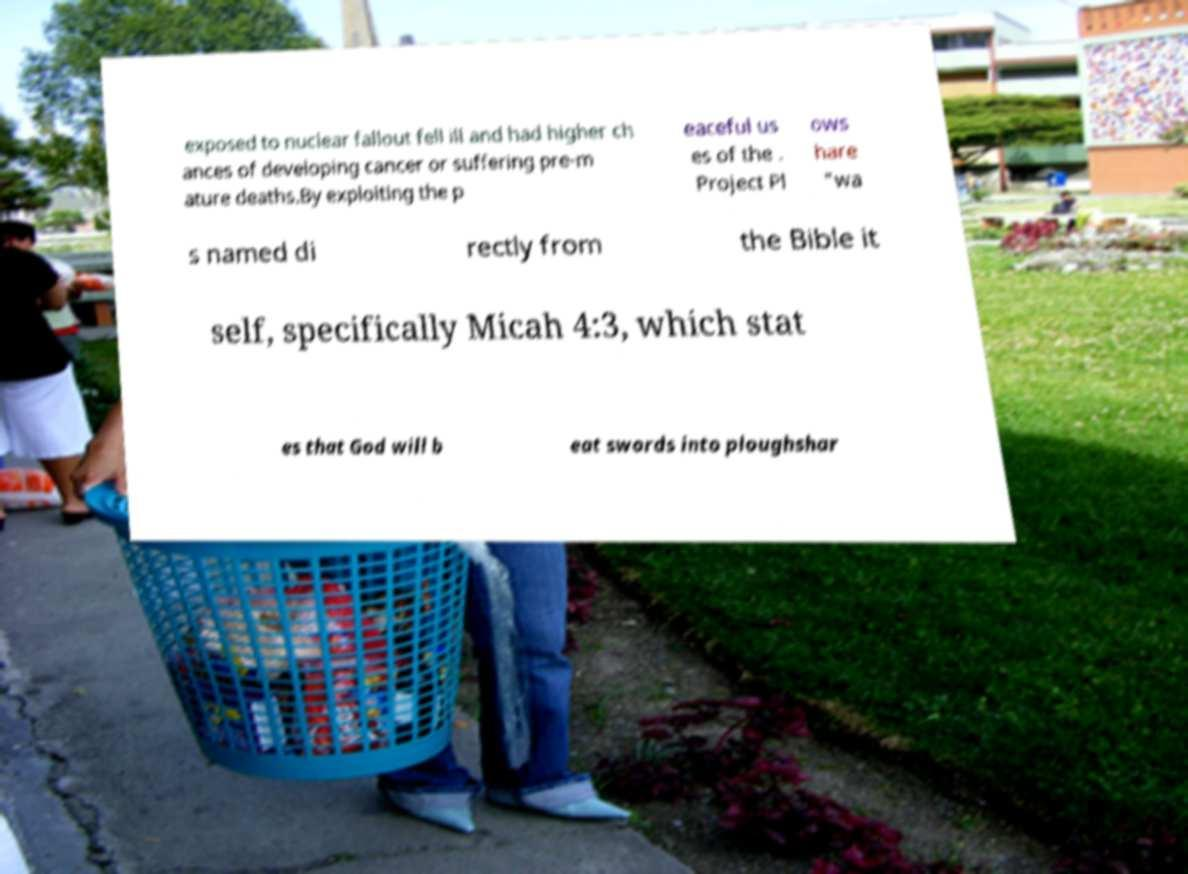Could you assist in decoding the text presented in this image and type it out clearly? exposed to nuclear fallout fell ill and had higher ch ances of developing cancer or suffering pre-m ature deaths.By exploiting the p eaceful us es of the . Project Pl ows hare "wa s named di rectly from the Bible it self, specifically Micah 4:3, which stat es that God will b eat swords into ploughshar 